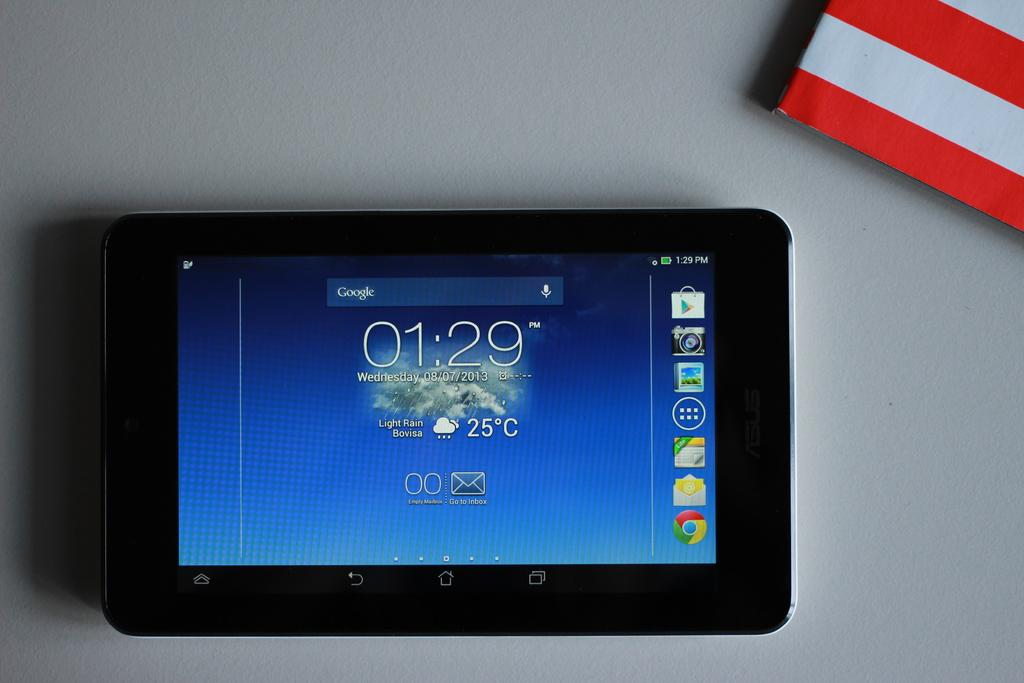What electronic device is visible in the image? There is an iPad in the image. What is the color of the iPad? The iPad is black in color. What other object with a distinct color pattern can be seen in the image? There is a red and white color object in the image. On what surface are the objects placed? The objects are on a white color surface. What type of shirt is the person wearing in the image? There is no person or shirt visible in the image; it only features an iPad, a red and white object, and a white surface. 